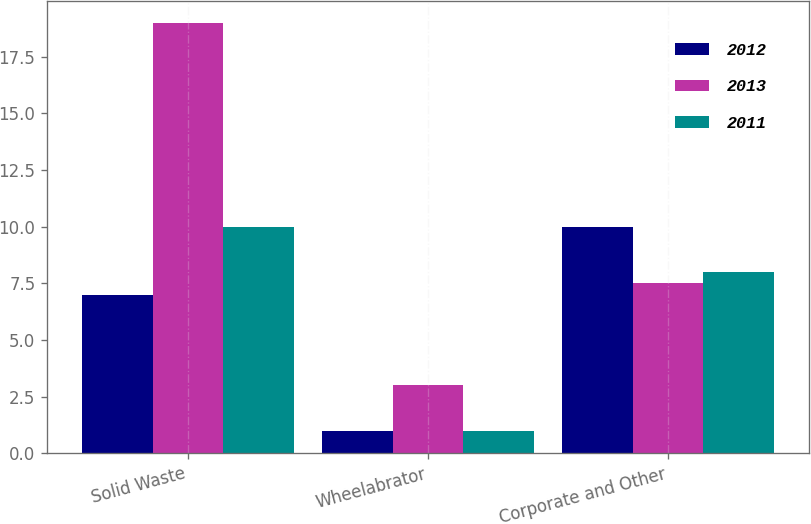<chart> <loc_0><loc_0><loc_500><loc_500><stacked_bar_chart><ecel><fcel>Solid Waste<fcel>Wheelabrator<fcel>Corporate and Other<nl><fcel>2012<fcel>7<fcel>1<fcel>10<nl><fcel>2013<fcel>19<fcel>3<fcel>7.5<nl><fcel>2011<fcel>10<fcel>1<fcel>8<nl></chart> 